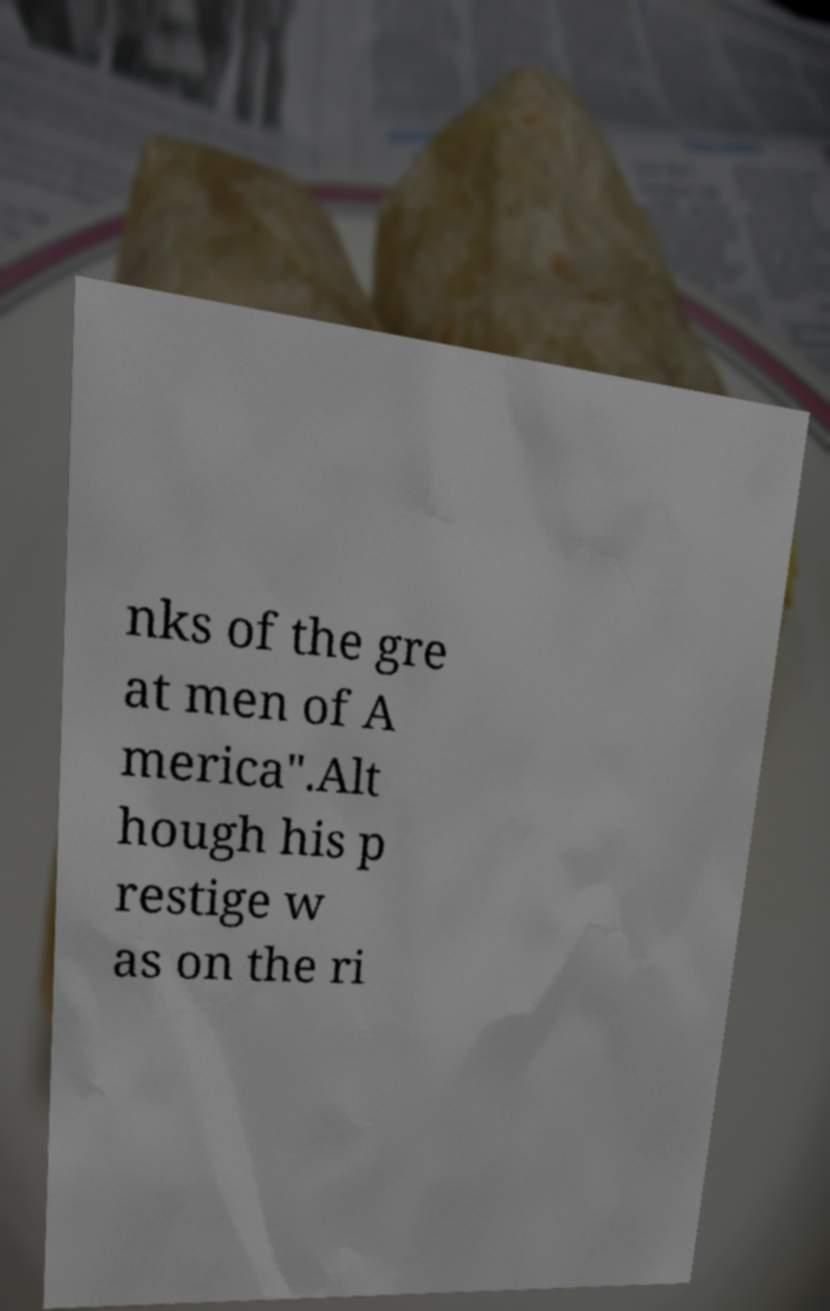Could you extract and type out the text from this image? nks of the gre at men of A merica".Alt hough his p restige w as on the ri 